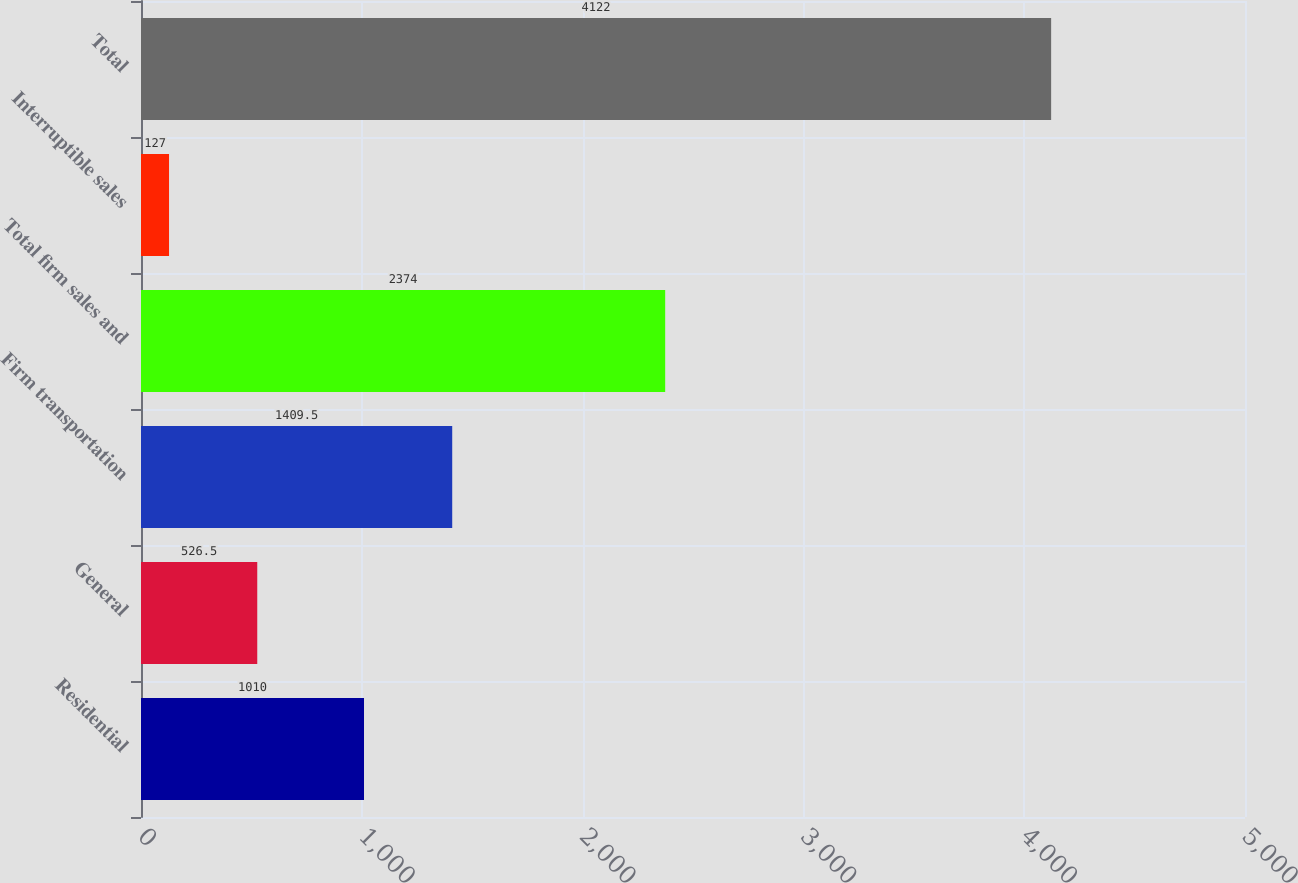Convert chart. <chart><loc_0><loc_0><loc_500><loc_500><bar_chart><fcel>Residential<fcel>General<fcel>Firm transportation<fcel>Total firm sales and<fcel>Interruptible sales<fcel>Total<nl><fcel>1010<fcel>526.5<fcel>1409.5<fcel>2374<fcel>127<fcel>4122<nl></chart> 